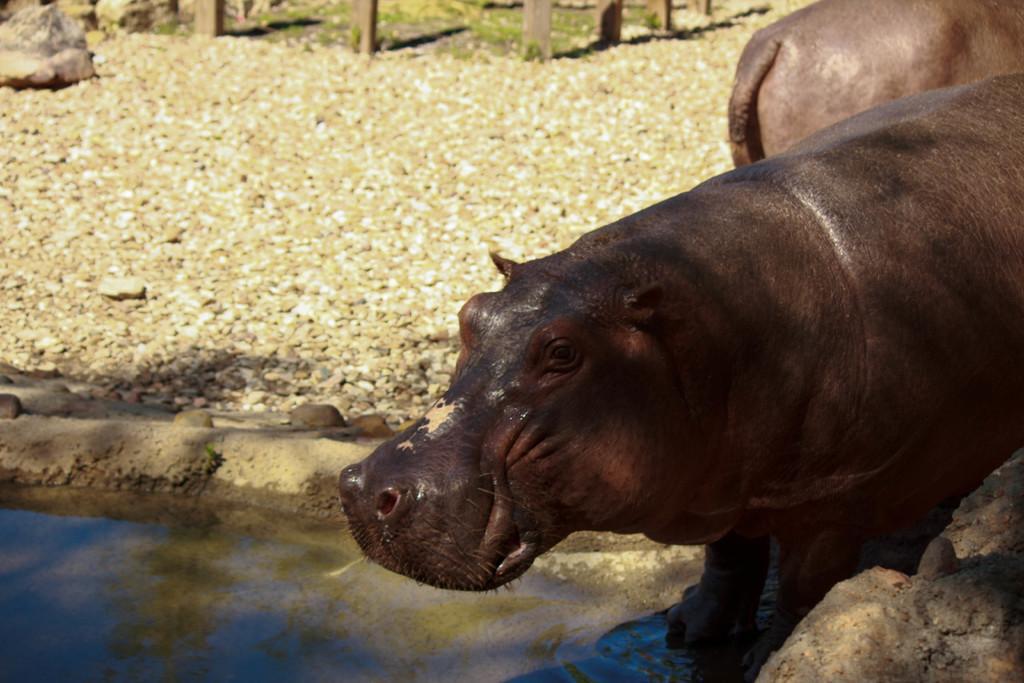How would you summarize this image in a sentence or two? In this picture we can see two animals. We can see the reflections of some objects on the water. There are a few stones, grass and wooden objects in the background. 